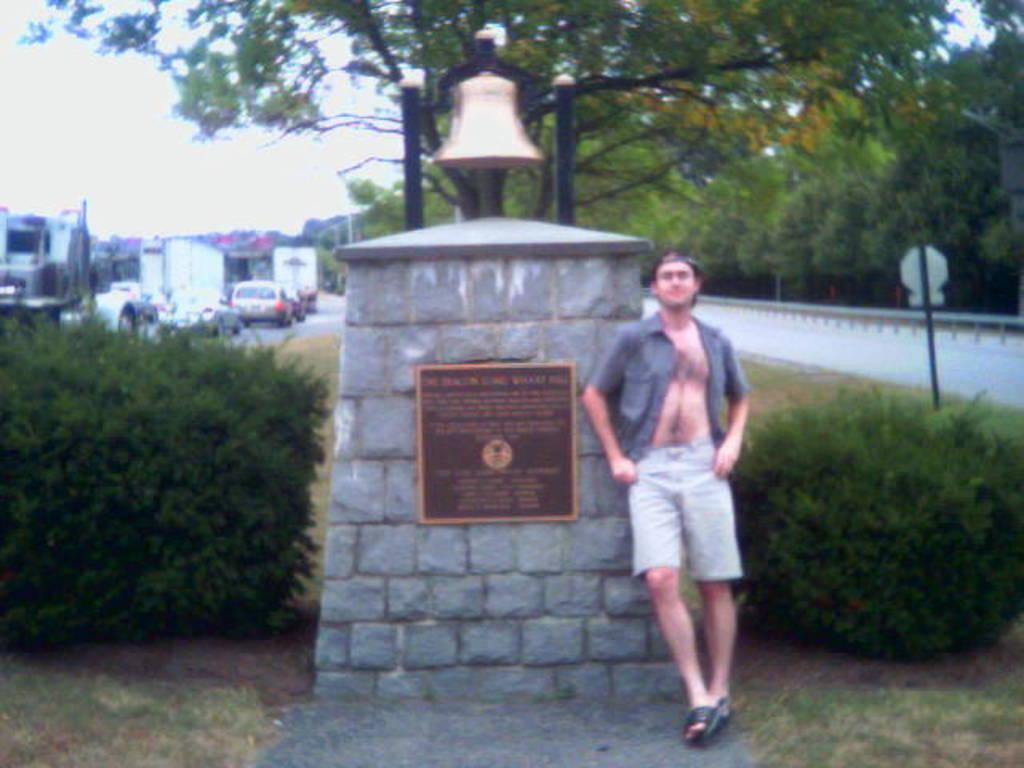Please provide a concise description of this image. In the picture we can see a man standing near the wall and on the top of the wall we can see a bell and on the either sides of the wall we can see plants and behind it, we can see a tree and on the other sites we can see roads and some vehicles on the road and in the background we can see a sky. 